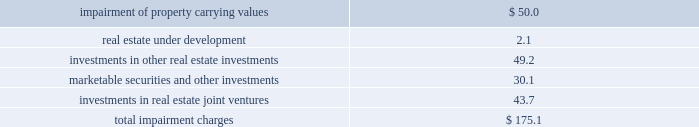Latin american investments during 2009 , the company acquired a land parcel located in rio clara , brazil through a newly formed consolidated joint venture in which the company has a 70% ( 70 % ) controlling ownership interest for a purchase price of 3.3 million brazilian reals ( approximately usd $ 1.5 million ) .
This parcel will be developed into a 48000 square foot retail shopping center .
Additionally , during 2009 , the company acquired a land parcel located in san luis potosi , mexico , through an unconsolidated joint venture in which the company has a noncontrolling interest , for an aggregate purchase price of approximately $ 0.8 million .
The company recognized equity in income from its unconsolidated mexican investments in real estate joint ventures of approximately $ 7.0 million , $ 17.1 million , and $ 5.2 million during 2009 , 2008 and 2007 , respectively .
The company recognized equity in income from its unconsolidated chilean investments in real estate joint ventures of approximately $ 0.4 million , $ 0.2 and $ 0.1 million during 2009 , 2008 and 2007 , respectively .
The company 2019s revenues from its consolidated mexican subsidiaries aggregated approximately $ 23.4 million , $ 20.3 million , $ 8.5 million during 2009 , 2008 and 2007 , respectively .
The company 2019s revenues from its consolidated brazilian subsidiaries aggregated approximately $ 1.5 million and $ 0.4 million during 2009 and 2008 , respectively .
The company 2019s revenues from its consolidated chilean subsidiaries aggregated less than $ 100000 during 2009 and 2008 , respectively .
Mortgages and other financing receivables during 2009 , the company provided financing to five borrowers for an aggregate amount of approximately $ 8.3 million .
During 2009 , the company received an aggregate of approximately $ 40.4 million which fully paid down the outstanding balance on four mortgage receivables .
As of december 31 , 2009 , the company had 37 loans with total commitments of up to $ 178.9 million , of which approximately $ 131.3 million has been funded .
Availability under the company 2019s revolving credit facilities are expected to be sufficient to fund these remaining commitments .
( see note 10 of the notes to consolidated financial statements included in this annual report on form 10-k. ) asset impairments on a continuous basis , management assesses whether there are any indicators , including property operating performance and general market conditions , that the value of the company 2019s assets ( including any related amortizable intangible assets or liabilities ) may be impaired .
To the extent impairment has occurred , the carrying value of the asset would be adjusted to an amount to reflect the estimated fair value of the asset .
During 2009 , economic conditions had continued to experience volatility resulting in further declines in the real estate and equity markets .
Year over year increases in capitalization rates , discount rates and vacancies as well as the deterioration of real estate market fundamentals , negatively impacted net operating income and leasing which further contributed to declines in real estate markets in general .
As a result of the volatility and declining market conditions described above , as well as the company 2019s strategy in relation to certain of its non-retail assets , the company recognized non-cash impairment charges during 2009 , aggregating approximately $ 175.1 million , before income tax benefit of approximately $ 22.5 million and noncontrolling interests of approximately $ 1.2 million .
Details of these non-cash impairment charges are as follows ( in millions ) : .
( see notes 2 , 6 , 8 , 9 , 10 and 11 of the notes to consolidated financial statements included in this annual report on form 10-k. ) .
As of dec 31 , 2009 , what was the average loan commitment for the company for all of its total loan commitments , in millions>? 
Computations: (178.9 / 37)
Answer: 4.83514. Latin american investments during 2009 , the company acquired a land parcel located in rio clara , brazil through a newly formed consolidated joint venture in which the company has a 70% ( 70 % ) controlling ownership interest for a purchase price of 3.3 million brazilian reals ( approximately usd $ 1.5 million ) .
This parcel will be developed into a 48000 square foot retail shopping center .
Additionally , during 2009 , the company acquired a land parcel located in san luis potosi , mexico , through an unconsolidated joint venture in which the company has a noncontrolling interest , for an aggregate purchase price of approximately $ 0.8 million .
The company recognized equity in income from its unconsolidated mexican investments in real estate joint ventures of approximately $ 7.0 million , $ 17.1 million , and $ 5.2 million during 2009 , 2008 and 2007 , respectively .
The company recognized equity in income from its unconsolidated chilean investments in real estate joint ventures of approximately $ 0.4 million , $ 0.2 and $ 0.1 million during 2009 , 2008 and 2007 , respectively .
The company 2019s revenues from its consolidated mexican subsidiaries aggregated approximately $ 23.4 million , $ 20.3 million , $ 8.5 million during 2009 , 2008 and 2007 , respectively .
The company 2019s revenues from its consolidated brazilian subsidiaries aggregated approximately $ 1.5 million and $ 0.4 million during 2009 and 2008 , respectively .
The company 2019s revenues from its consolidated chilean subsidiaries aggregated less than $ 100000 during 2009 and 2008 , respectively .
Mortgages and other financing receivables during 2009 , the company provided financing to five borrowers for an aggregate amount of approximately $ 8.3 million .
During 2009 , the company received an aggregate of approximately $ 40.4 million which fully paid down the outstanding balance on four mortgage receivables .
As of december 31 , 2009 , the company had 37 loans with total commitments of up to $ 178.9 million , of which approximately $ 131.3 million has been funded .
Availability under the company 2019s revolving credit facilities are expected to be sufficient to fund these remaining commitments .
( see note 10 of the notes to consolidated financial statements included in this annual report on form 10-k. ) asset impairments on a continuous basis , management assesses whether there are any indicators , including property operating performance and general market conditions , that the value of the company 2019s assets ( including any related amortizable intangible assets or liabilities ) may be impaired .
To the extent impairment has occurred , the carrying value of the asset would be adjusted to an amount to reflect the estimated fair value of the asset .
During 2009 , economic conditions had continued to experience volatility resulting in further declines in the real estate and equity markets .
Year over year increases in capitalization rates , discount rates and vacancies as well as the deterioration of real estate market fundamentals , negatively impacted net operating income and leasing which further contributed to declines in real estate markets in general .
As a result of the volatility and declining market conditions described above , as well as the company 2019s strategy in relation to certain of its non-retail assets , the company recognized non-cash impairment charges during 2009 , aggregating approximately $ 175.1 million , before income tax benefit of approximately $ 22.5 million and noncontrolling interests of approximately $ 1.2 million .
Details of these non-cash impairment charges are as follows ( in millions ) : .
( see notes 2 , 6 , 8 , 9 , 10 and 11 of the notes to consolidated financial statements included in this annual report on form 10-k. ) .
What percentage of non-cash impairment charges came from real estate under development? 
Computations: (2.1 / 175.1)
Answer: 0.01199. 